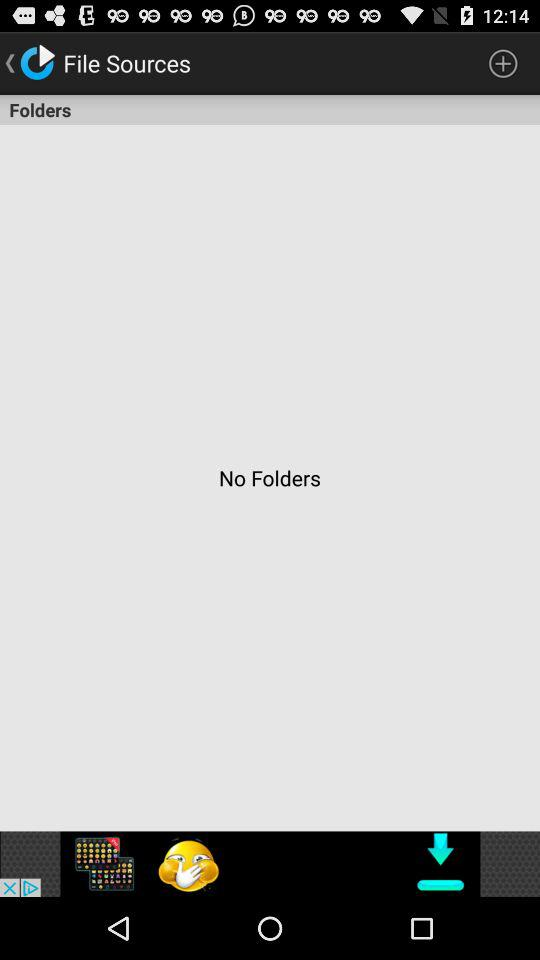What is the name of application?
When the provided information is insufficient, respond with <no answer>. <no answer> 